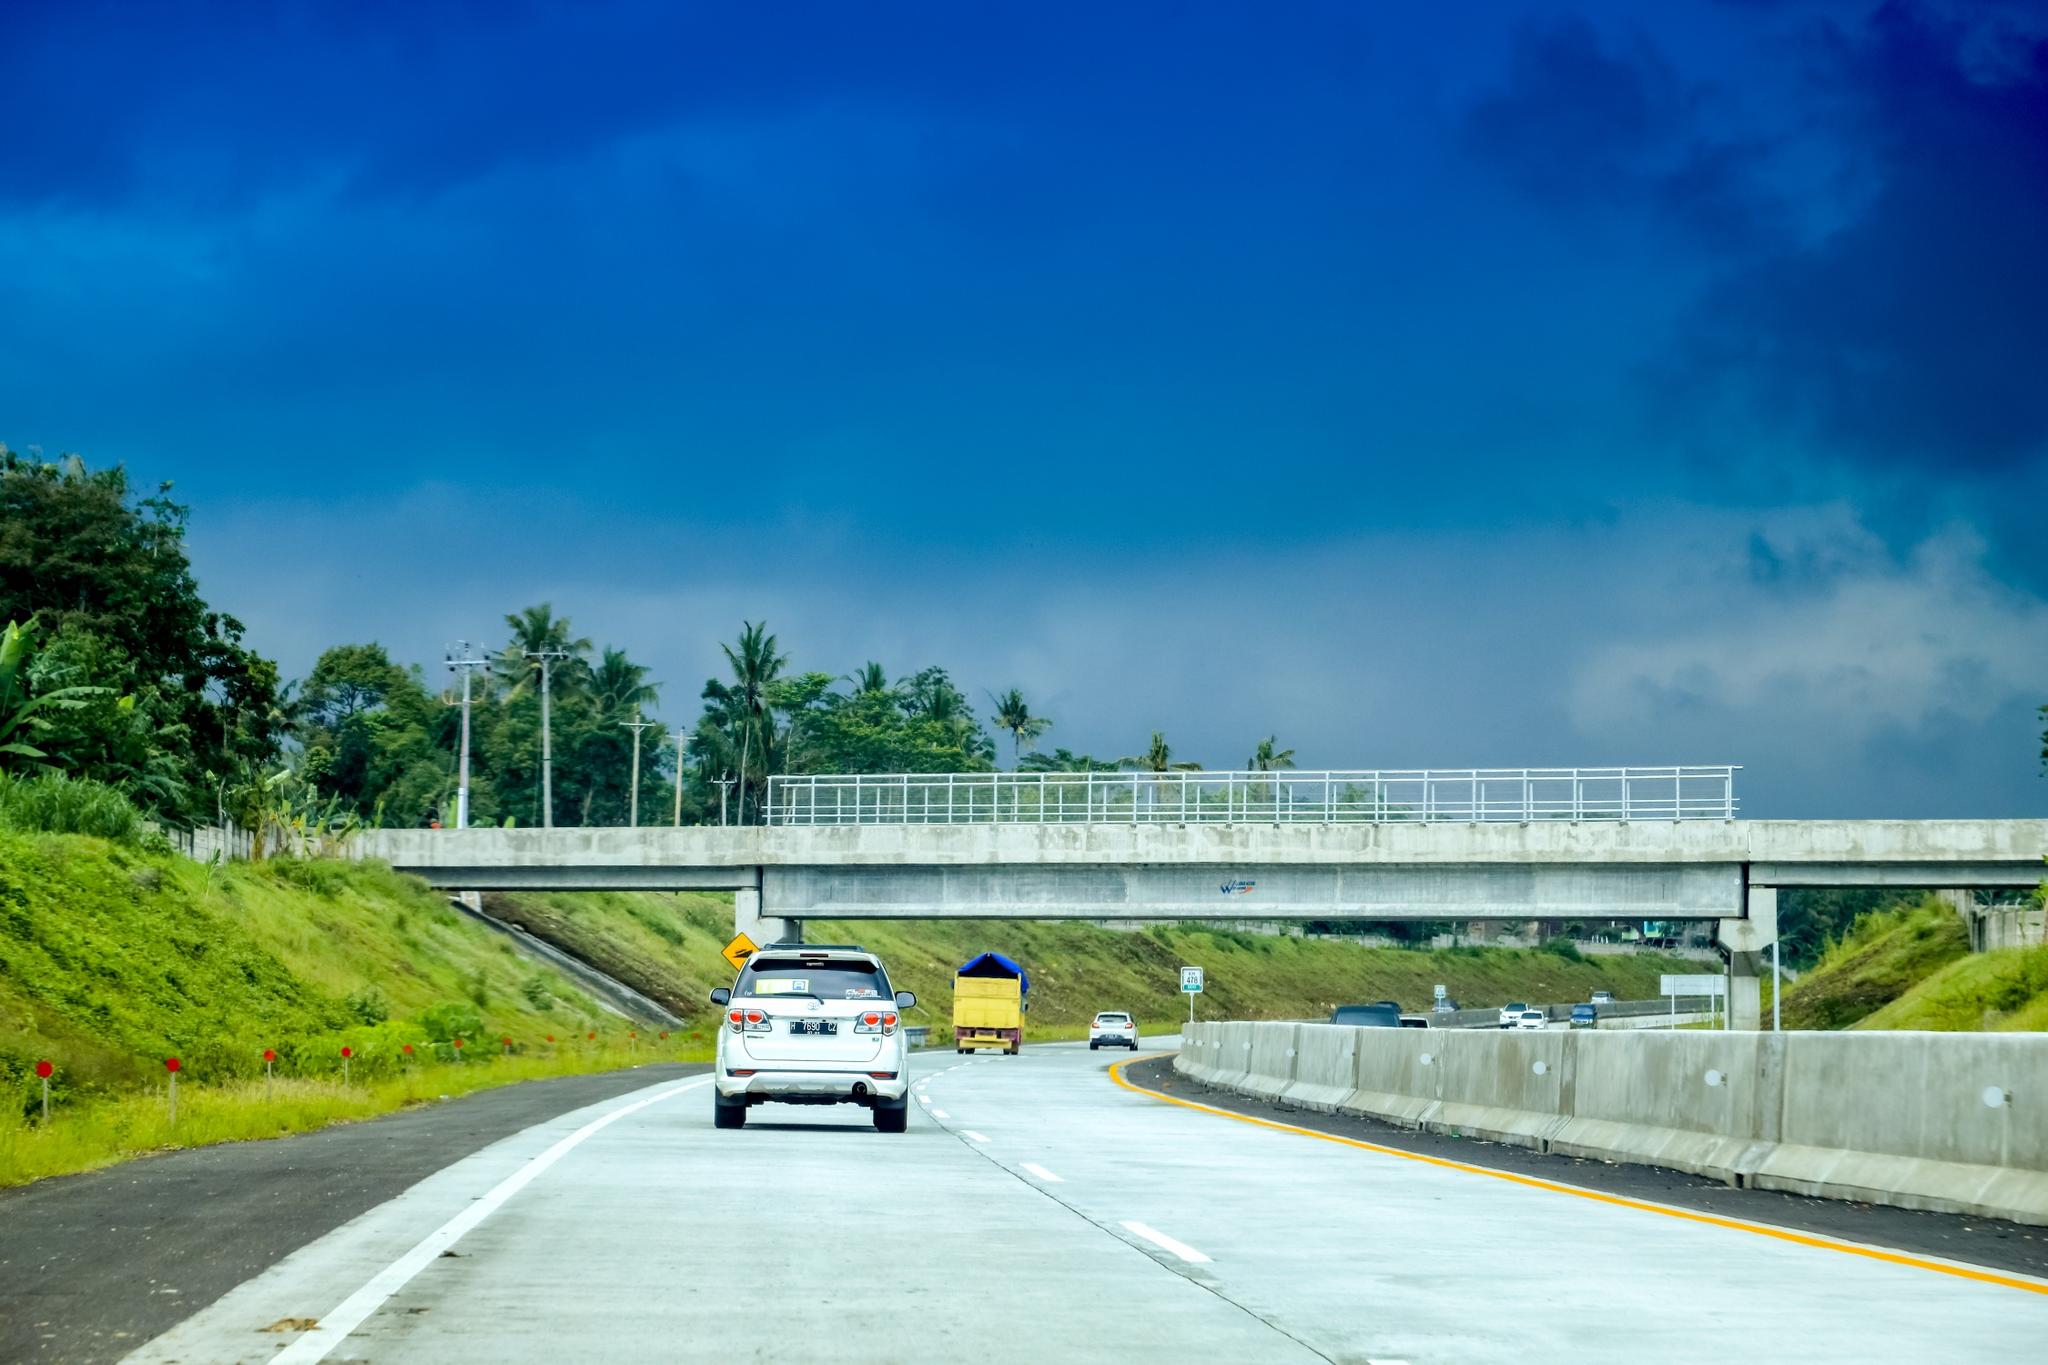Can you describe the main features of this image for me? The image beautifully captures the serene ambiance of a highway in the Philippines, seen from within a moving car. The road, appearing as a smooth gray ribbon, extends into the horizon, flanked by verdant greenery and tall palm trees that cast dancing shadows on the surface. A white car in the foreground, likely part of the journey, adds a dynamic element, emphasizing motion. Ahead, a sturdy concrete bridge spans the highway, guiding the eye toward the distant vanishing point. Above, the sky is a stunning bright blue, interspersed with fluffy white clouds, highlighting the sunny, tropical atmosphere. The image conveys a sense of peaceful travel through an idyllic landscape. 